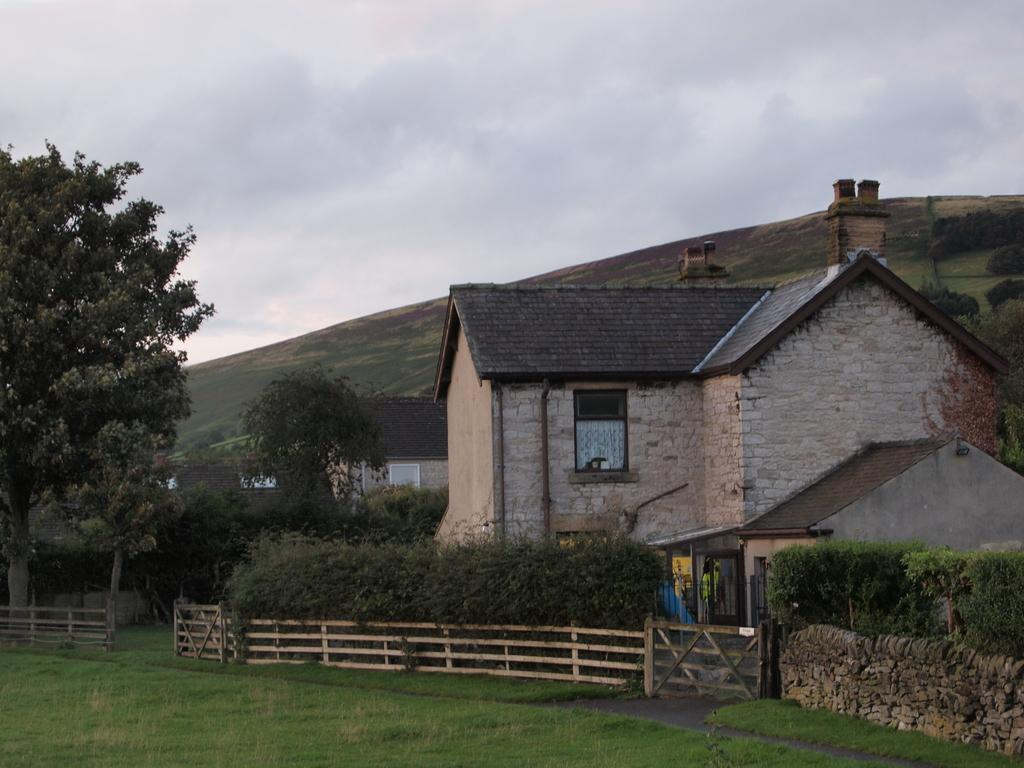What type of structures can be seen in the image? There are houses in the image. What type of vegetation is present in the image? There are trees, plants, and grass in the image. What can be seen hanging in the image? There are clothes hanging in the image. What type of barrier is visible in the image? There is a fence in the image. What is the natural feature in the background of the image? There is a hill in the image. What is visible at the top of the image? The sky is visible at the top of the image. What type of butter can be seen in the image? There is no butter present in the image. 